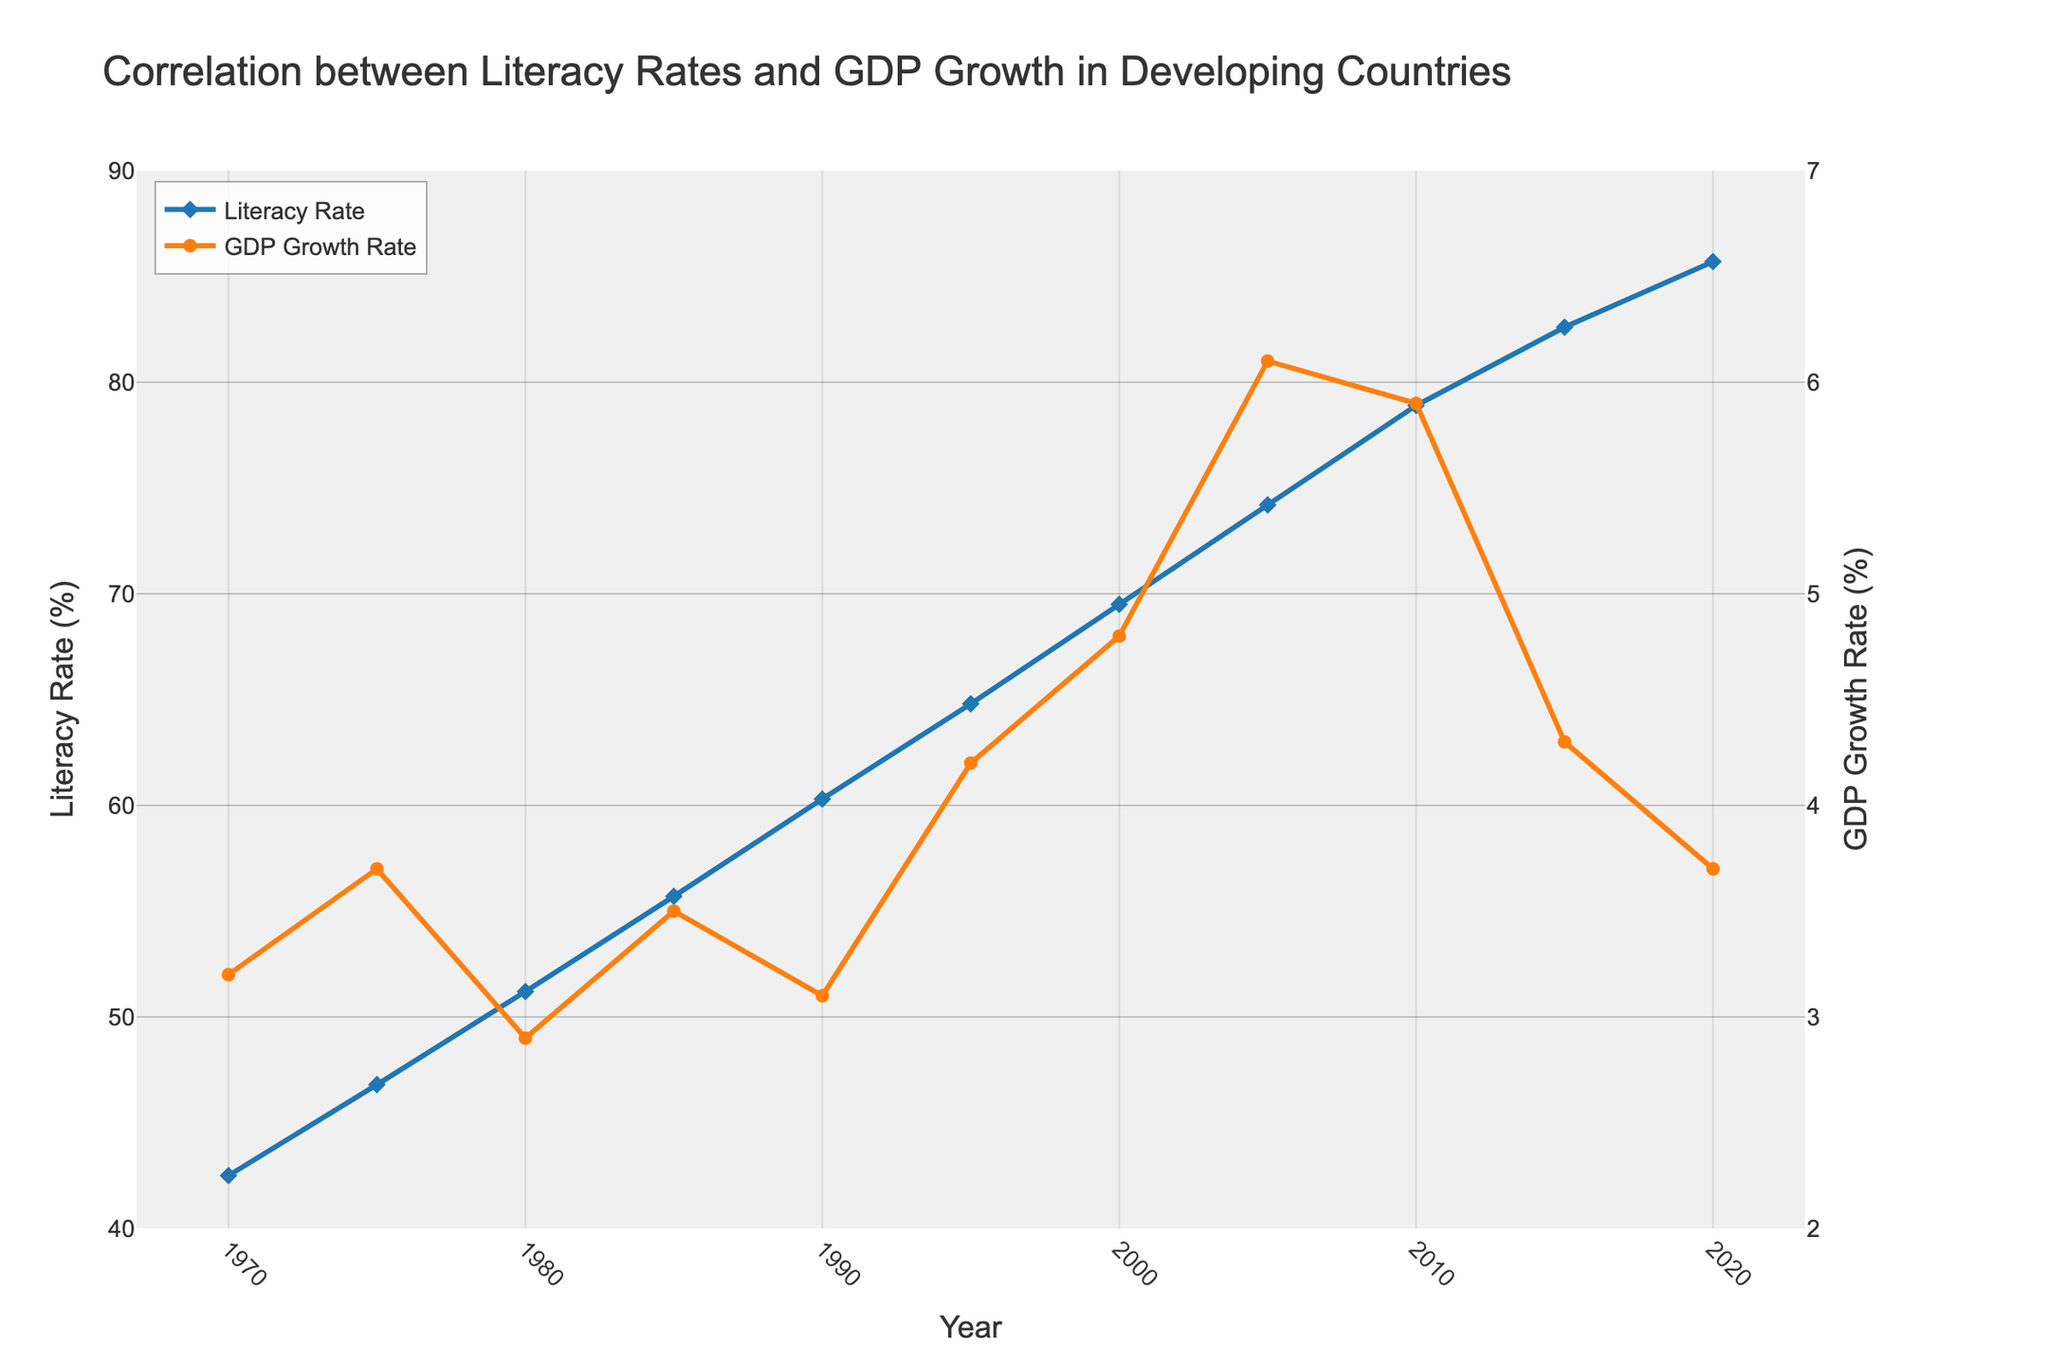What year did the Literacy Rate and GDP Growth Rate reach their highest values in the given period? The highest Literacy Rate occurs in 2020 at 85.7%. The highest GDP Growth Rate occurs in 2005 at 6.1%.
Answer: 2020, 2005 By how many percentage points did the Literacy Rate increase from 1970 to 2020? The Literacy Rate in 1970 was 42.5%, and in 2020 it was 85.7%. The difference is 85.7% - 42.5% = 43.2 percentage points.
Answer: 43.2 In which year did both Literacy Rate and GDP Growth Rate experience a similar value? In 1970, the Literacy Rate was 42.5% and the GDP Growth Rate was 3.2%. These rates are numerically close to each other compared to other years.
Answer: 1970 What is the average GDP Growth Rate from 2000 to 2020? The GDP Growth Rates from 2000 to 2020 are 4.8%, 6.1%, 5.9%, 4.3%, and 3.7%. The sum of these rates is 4.8 + 6.1 + 5.9 + 4.3 + 3.7 = 24.8%. The average is 24.8 / 5 = 4.96%.
Answer: 4.96 Which had a more significant change from 1970 to 1980, Literacy Rate or GDP Growth Rate? From 1970 to 1980, the Literacy Rate increased from 42.5% to 51.2%, a change of 8.7 percentage points. The GDP Growth Rate changed from 3.2% to 2.9%, a decrease of 0.3 percentage points. The Literacy Rate had a more significant change.
Answer: Literacy Rate Compare the trends of Literacy Rate and GDP Growth Rate in the period from 2005 to 2010. From 2005 to 2010, the Literacy Rate increased from 74.2% to 78.9%, showing a rising trend. Meanwhile, the GDP Growth Rate decreased from 6.1% to 5.9%, showing a slight downward trend.
Answer: Literacy Rate increased, GDP Growth Rate decreased Is there a year where the GDP Growth Rate was higher than the Literacy Rate? There is no year where the GDP Growth Rate outpaced the Literacy Rate.
Answer: No In which year did the GDP Growth Rate experience the most significant drop compared to the previous year? The most significant drop in GDP Growth Rate occurred from 2010 to 2015, where it fell from 5.9% to 4.3%, a reduction of 1.6 percentage points.
Answer: Between 2010 and 2015 What is the general trend observed for Literacy Rate and GDP Growth Rate from 1970 to 2020? Over the period from 1970 to 2020, the general trend for the Literacy Rate is an upward increase, and the GDP Growth Rate shows a more fluctuating pattern with periods of rise and fall.
Answer: Literacy Rate increased, GDP Growth Rate fluctuated In which five-year period did the Literacy Rate see the smallest increase? The smallest increase in Literacy Rate occurred between 2015 and 2020, where it increased from 82.6% to 85.7%, an increase of 3.1 percentage points.
Answer: 2015-2020 